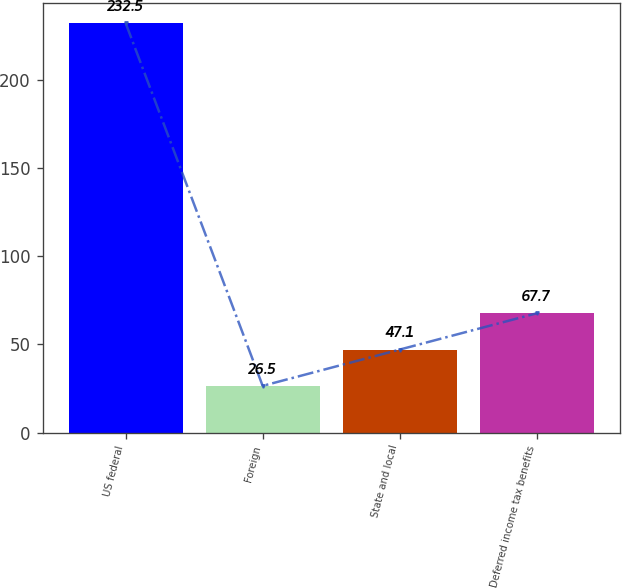Convert chart. <chart><loc_0><loc_0><loc_500><loc_500><bar_chart><fcel>US federal<fcel>Foreign<fcel>State and local<fcel>Deferred income tax benefits<nl><fcel>232.5<fcel>26.5<fcel>47.1<fcel>67.7<nl></chart> 